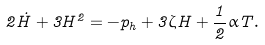<formula> <loc_0><loc_0><loc_500><loc_500>2 \dot { H } + 3 H ^ { 2 } = - p _ { h } + 3 \zeta H + \frac { 1 } { 2 } \alpha T .</formula> 